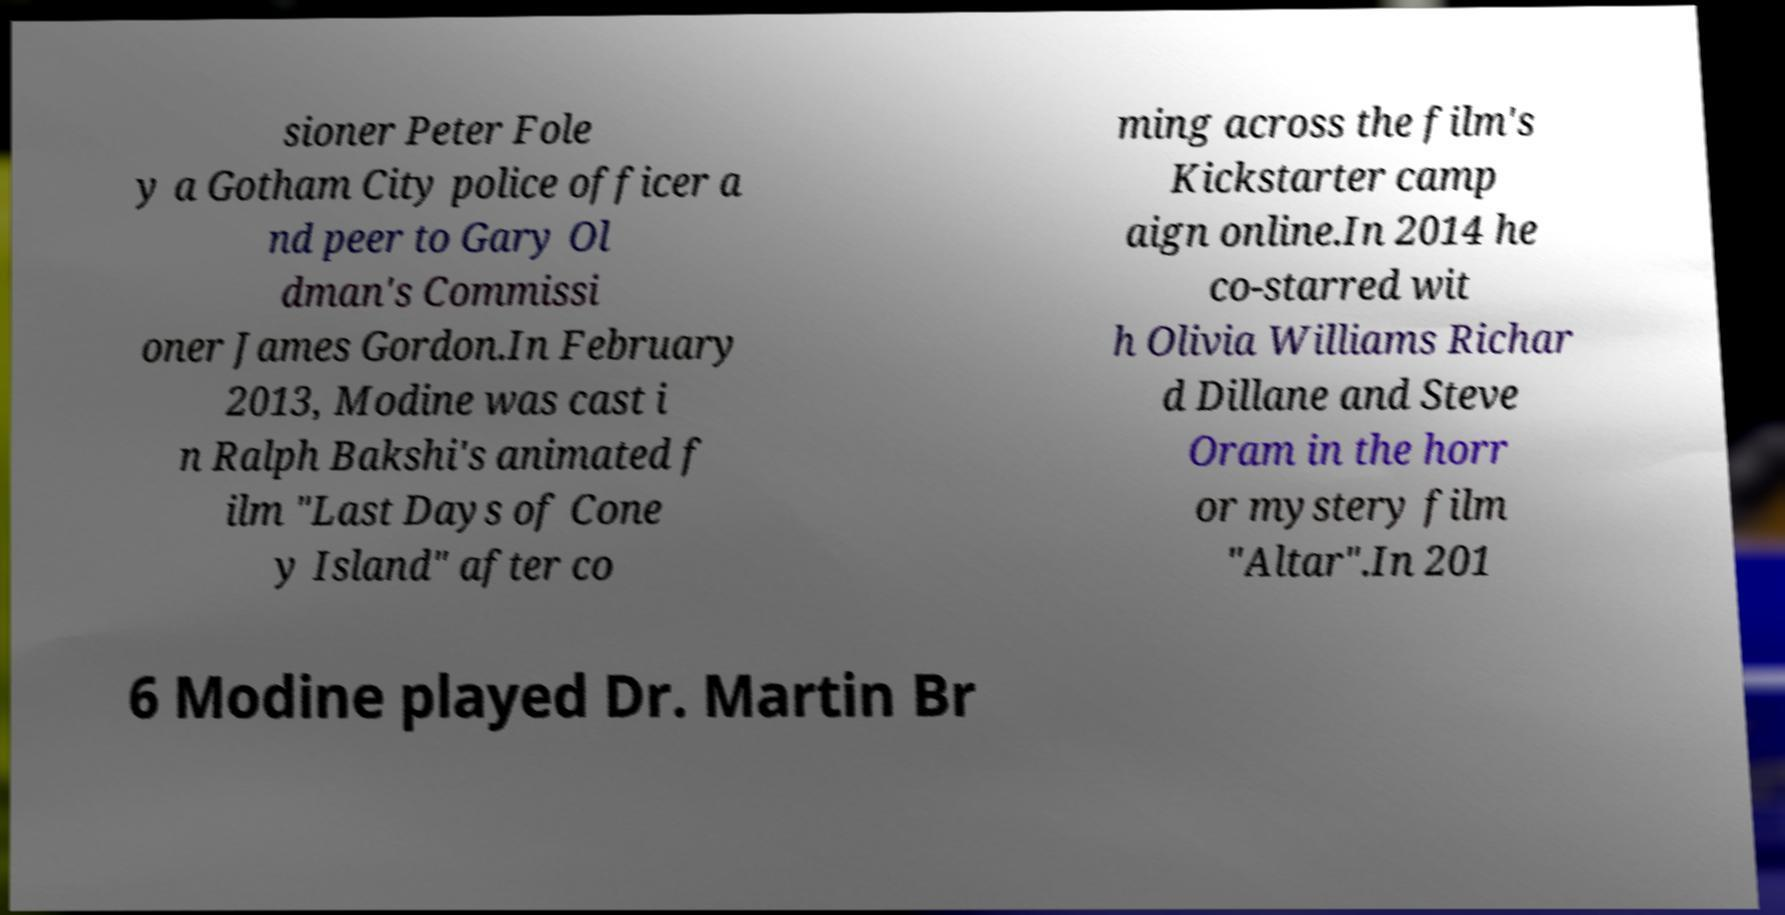For documentation purposes, I need the text within this image transcribed. Could you provide that? sioner Peter Fole y a Gotham City police officer a nd peer to Gary Ol dman's Commissi oner James Gordon.In February 2013, Modine was cast i n Ralph Bakshi's animated f ilm "Last Days of Cone y Island" after co ming across the film's Kickstarter camp aign online.In 2014 he co-starred wit h Olivia Williams Richar d Dillane and Steve Oram in the horr or mystery film "Altar".In 201 6 Modine played Dr. Martin Br 